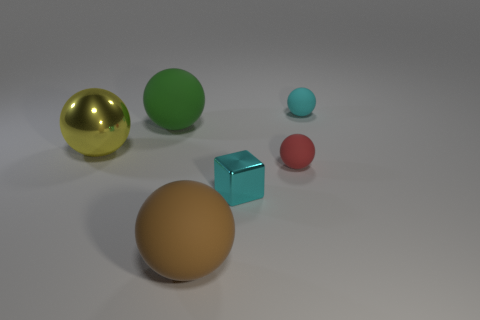How many things are either big rubber spheres in front of the small cyan metal object or large yellow blocks?
Your answer should be very brief. 1. Do the green rubber sphere and the yellow shiny sphere have the same size?
Provide a succinct answer. Yes. The small sphere that is behind the big green thing is what color?
Your answer should be compact. Cyan. There is a green ball that is the same material as the red ball; what is its size?
Provide a short and direct response. Large. There is a cyan shiny block; is it the same size as the cyan thing that is behind the big yellow metal thing?
Provide a short and direct response. Yes. What is the material of the tiny ball behind the yellow shiny sphere?
Provide a short and direct response. Rubber. There is a thing that is in front of the cyan cube; what number of big rubber things are behind it?
Provide a succinct answer. 1. Are there any other small objects that have the same shape as the yellow metal thing?
Your answer should be compact. Yes. There is a cyan object in front of the tiny cyan matte ball; is it the same size as the cyan thing right of the small red ball?
Provide a succinct answer. Yes. The metallic object left of the large green object that is behind the cyan cube is what shape?
Provide a succinct answer. Sphere. 